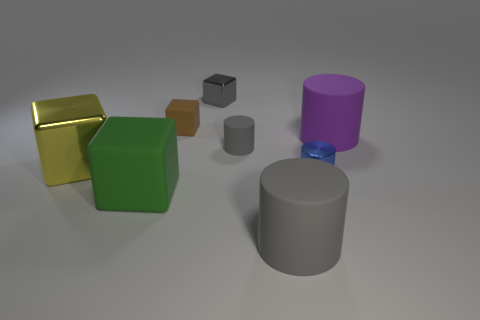Subtract 1 cubes. How many cubes are left? 3 Add 1 gray rubber things. How many objects exist? 9 Subtract 1 purple cylinders. How many objects are left? 7 Subtract all red objects. Subtract all tiny gray rubber things. How many objects are left? 7 Add 6 blue shiny objects. How many blue shiny objects are left? 7 Add 2 purple blocks. How many purple blocks exist? 2 